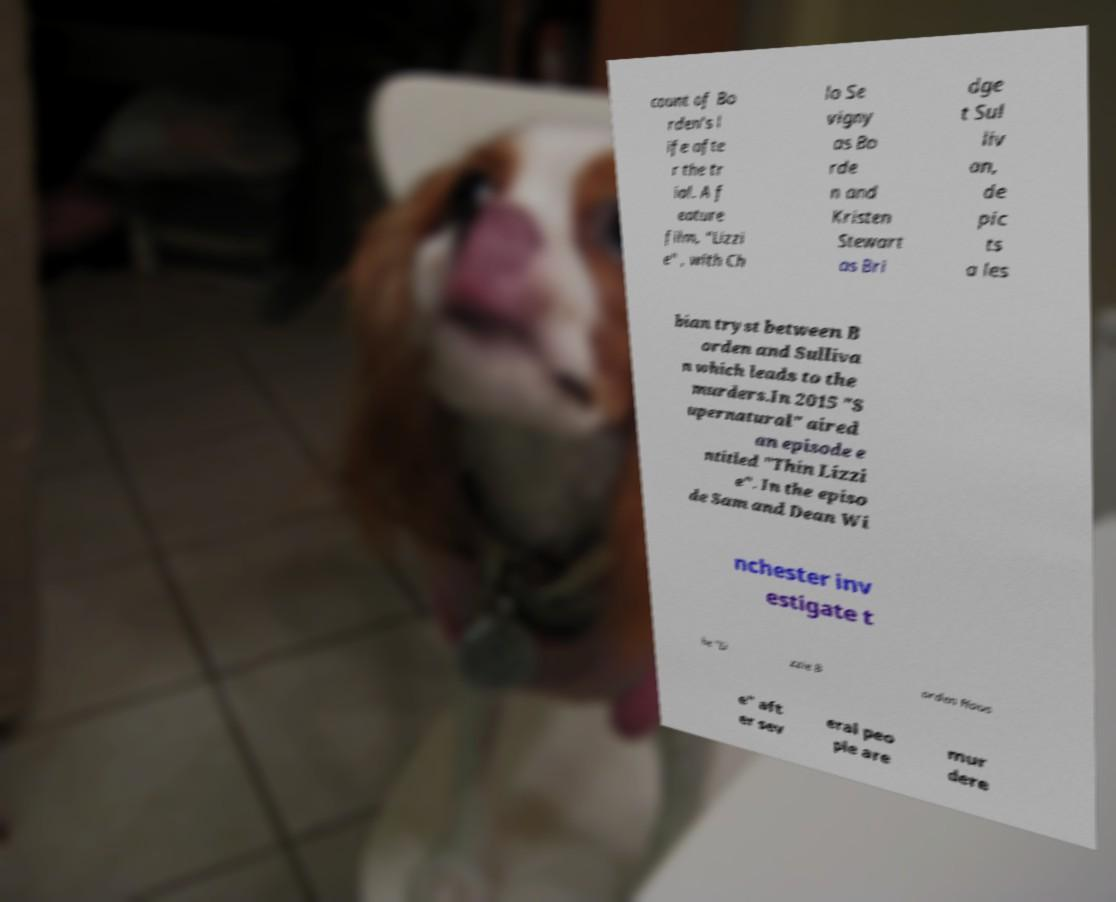Can you accurately transcribe the text from the provided image for me? count of Bo rden's l ife afte r the tr ial. A f eature film, "Lizzi e" , with Ch lo Se vigny as Bo rde n and Kristen Stewart as Bri dge t Sul liv an, de pic ts a les bian tryst between B orden and Sulliva n which leads to the murders.In 2015 "S upernatural" aired an episode e ntitled "Thin Lizzi e". In the episo de Sam and Dean Wi nchester inv estigate t he "Li zzie B orden Hous e" aft er sev eral peo ple are mur dere 